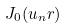Convert formula to latex. <formula><loc_0><loc_0><loc_500><loc_500>J _ { 0 } ( u _ { n } r )</formula> 